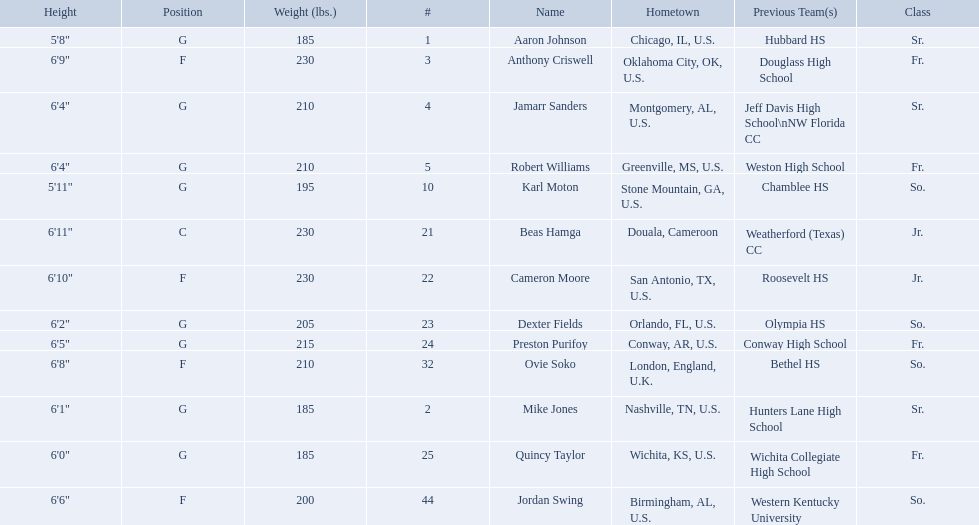Who are all the players? Aaron Johnson, Anthony Criswell, Jamarr Sanders, Robert Williams, Karl Moton, Beas Hamga, Cameron Moore, Dexter Fields, Preston Purifoy, Ovie Soko, Mike Jones, Quincy Taylor, Jordan Swing. Of these, which are not soko? Aaron Johnson, Anthony Criswell, Jamarr Sanders, Robert Williams, Karl Moton, Beas Hamga, Cameron Moore, Dexter Fields, Preston Purifoy, Mike Jones, Quincy Taylor, Jordan Swing. Where are these players from? Sr., Fr., Sr., Fr., So., Jr., Jr., So., Fr., Sr., Fr., So. Of these locations, which are not in the u.s.? Jr. Which player is from this location? Beas Hamga. 